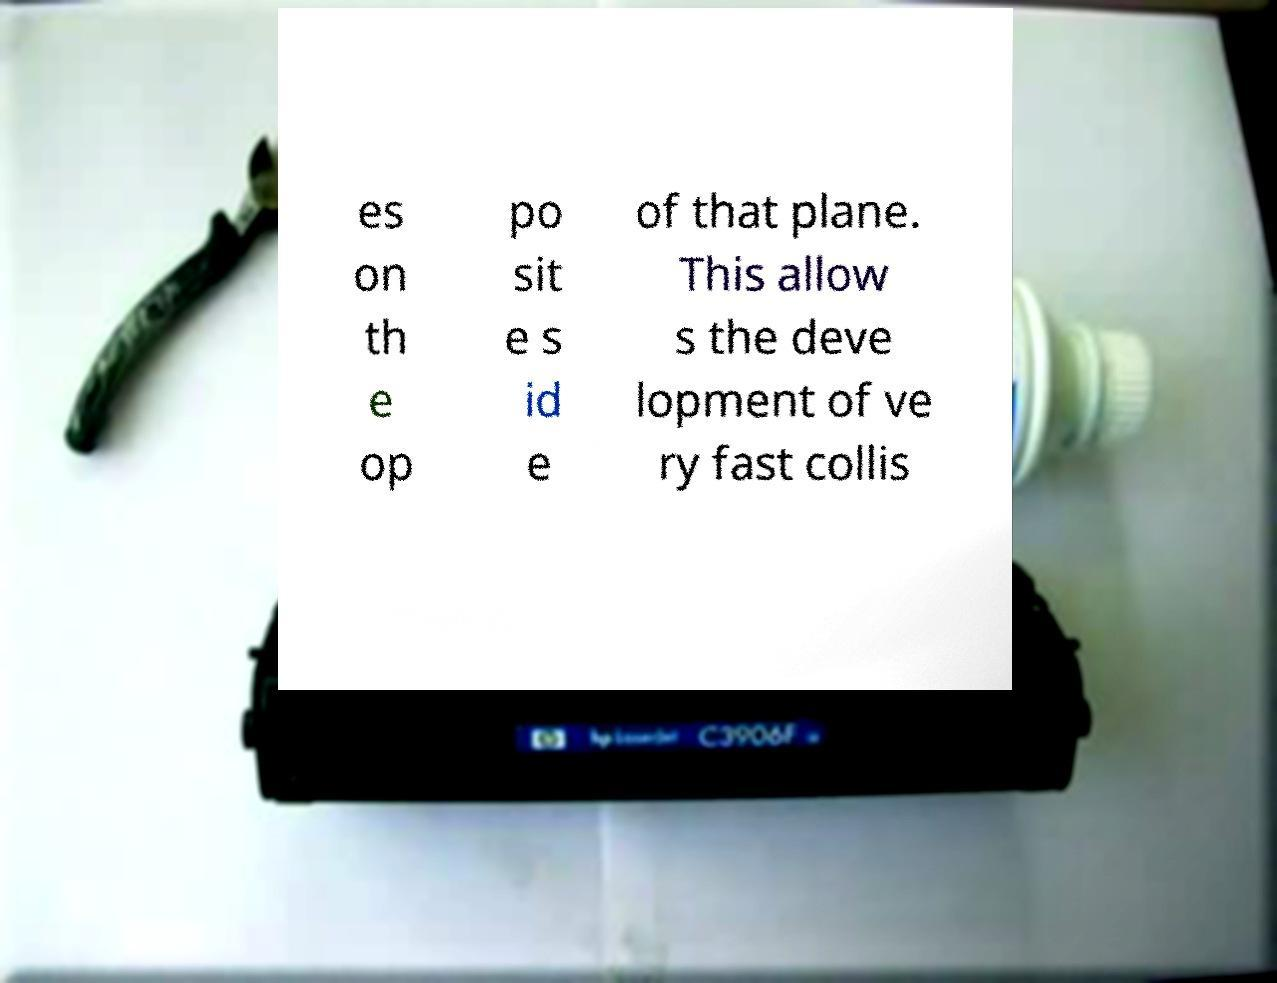For documentation purposes, I need the text within this image transcribed. Could you provide that? es on th e op po sit e s id e of that plane. This allow s the deve lopment of ve ry fast collis 